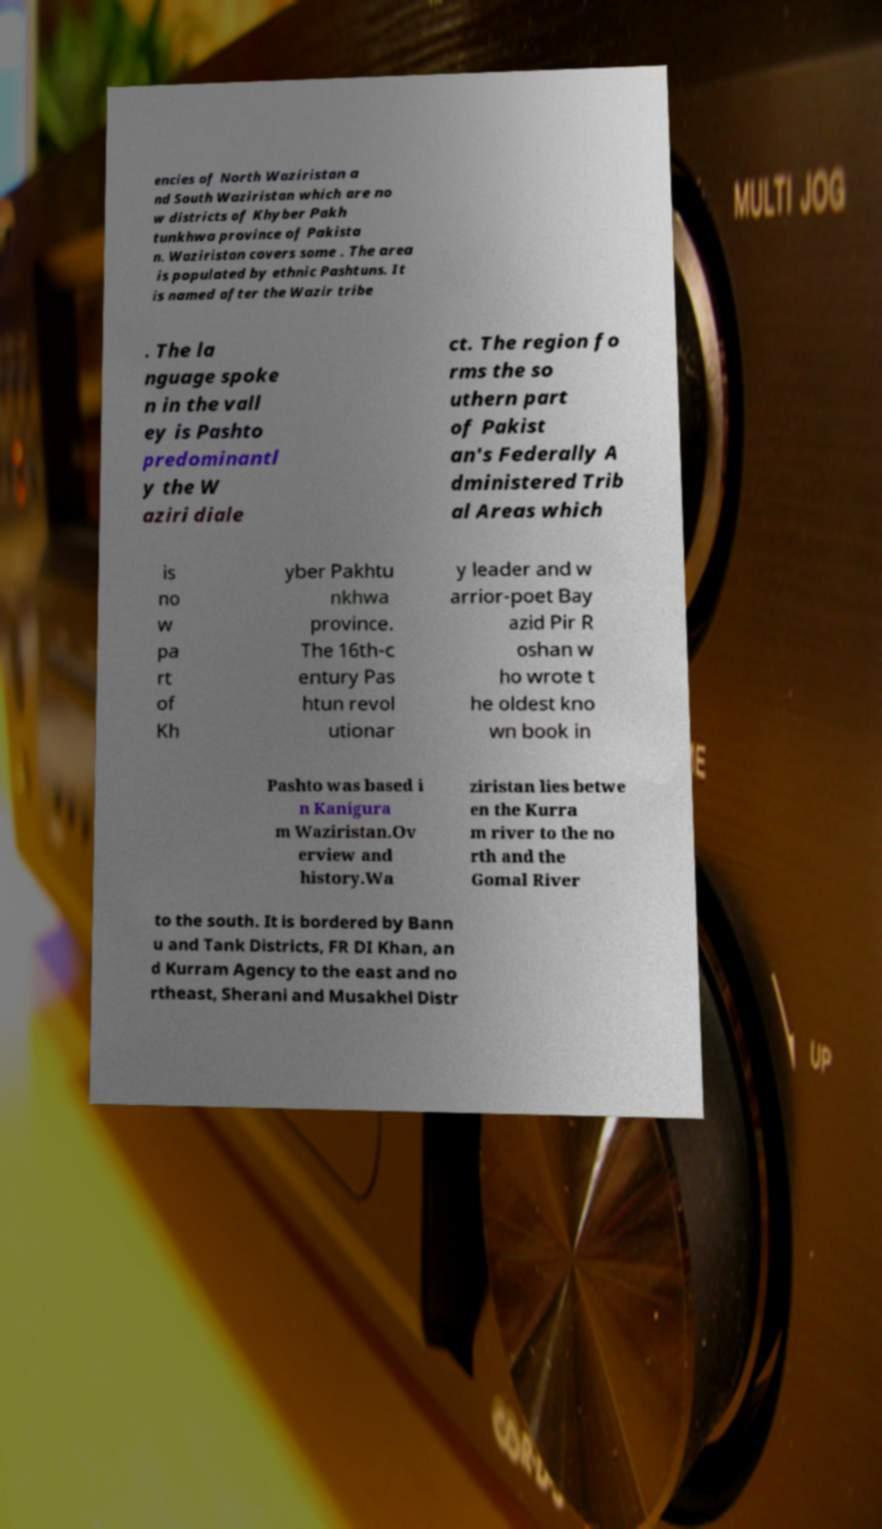Please identify and transcribe the text found in this image. encies of North Waziristan a nd South Waziristan which are no w districts of Khyber Pakh tunkhwa province of Pakista n. Waziristan covers some . The area is populated by ethnic Pashtuns. It is named after the Wazir tribe . The la nguage spoke n in the vall ey is Pashto predominantl y the W aziri diale ct. The region fo rms the so uthern part of Pakist an's Federally A dministered Trib al Areas which is no w pa rt of Kh yber Pakhtu nkhwa province. The 16th-c entury Pas htun revol utionar y leader and w arrior-poet Bay azid Pir R oshan w ho wrote t he oldest kno wn book in Pashto was based i n Kanigura m Waziristan.Ov erview and history.Wa ziristan lies betwe en the Kurra m river to the no rth and the Gomal River to the south. It is bordered by Bann u and Tank Districts, FR DI Khan, an d Kurram Agency to the east and no rtheast, Sherani and Musakhel Distr 